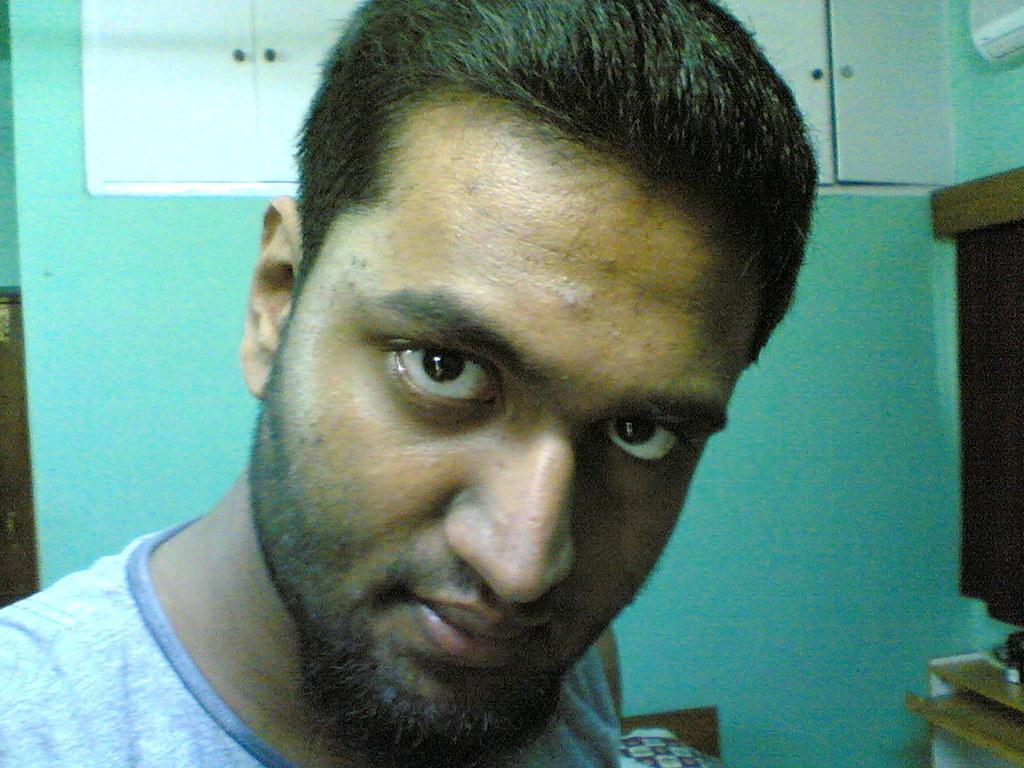Could you give a brief overview of what you see in this image? In this image in the foreground there is one man, and in the background there is wall, cupboards. And on the right side there is a curtain, table, air conditioner and objects. And at the bottom it looks like a bed. 